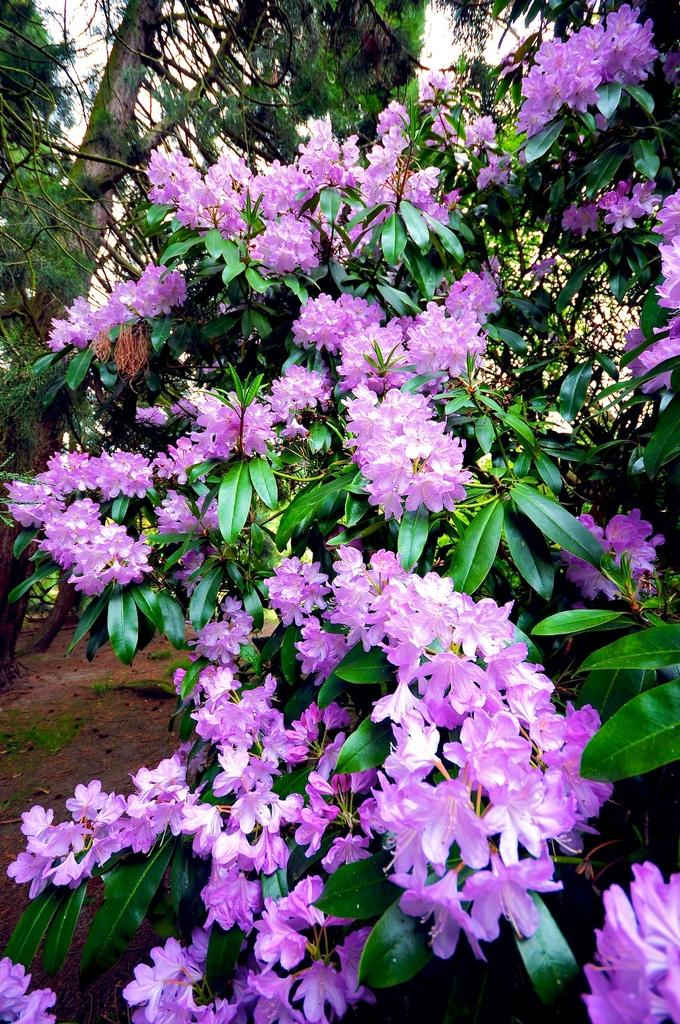What type of plants can be seen in the image? There are flowers and trees in the image. What part of the natural environment is visible in the image? The sky is visible in the background of the image. How many toes can be seen on the flowers in the image? There are no toes visible in the image, as flowers do not have toes. 